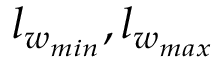Convert formula to latex. <formula><loc_0><loc_0><loc_500><loc_500>l _ { w _ { \min } } , l _ { w _ { \max } }</formula> 